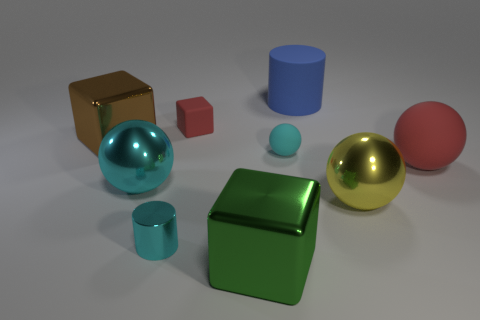How many things are small green objects or things that are on the left side of the yellow object?
Provide a succinct answer. 7. Is the material of the yellow sphere the same as the small cyan ball?
Keep it short and to the point. No. What number of other objects are the same material as the tiny block?
Keep it short and to the point. 3. Are there more big yellow objects than gray matte cylinders?
Your answer should be compact. Yes. Is the shape of the red matte object that is behind the tiny cyan sphere the same as  the brown shiny thing?
Provide a succinct answer. Yes. Are there fewer tiny blue metal blocks than tiny matte blocks?
Your answer should be compact. Yes. What material is the cylinder that is the same size as the yellow shiny object?
Provide a succinct answer. Rubber. Is the color of the large rubber ball the same as the small matte object behind the brown thing?
Your answer should be very brief. Yes. Is the number of cyan metallic things right of the small cyan rubber object less than the number of balls?
Provide a succinct answer. Yes. What number of small things are there?
Your answer should be compact. 3. 